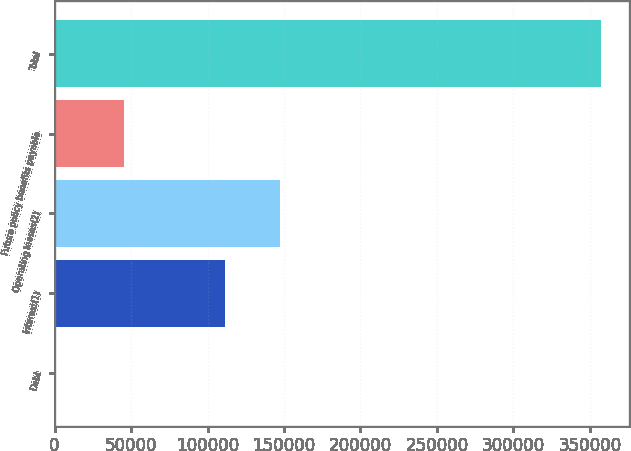Convert chart. <chart><loc_0><loc_0><loc_500><loc_500><bar_chart><fcel>Debt<fcel>Interest(1)<fcel>Operating leases(2)<fcel>Future policy benefits payable<fcel>Total<nl><fcel>540<fcel>111734<fcel>147424<fcel>45656<fcel>357443<nl></chart> 